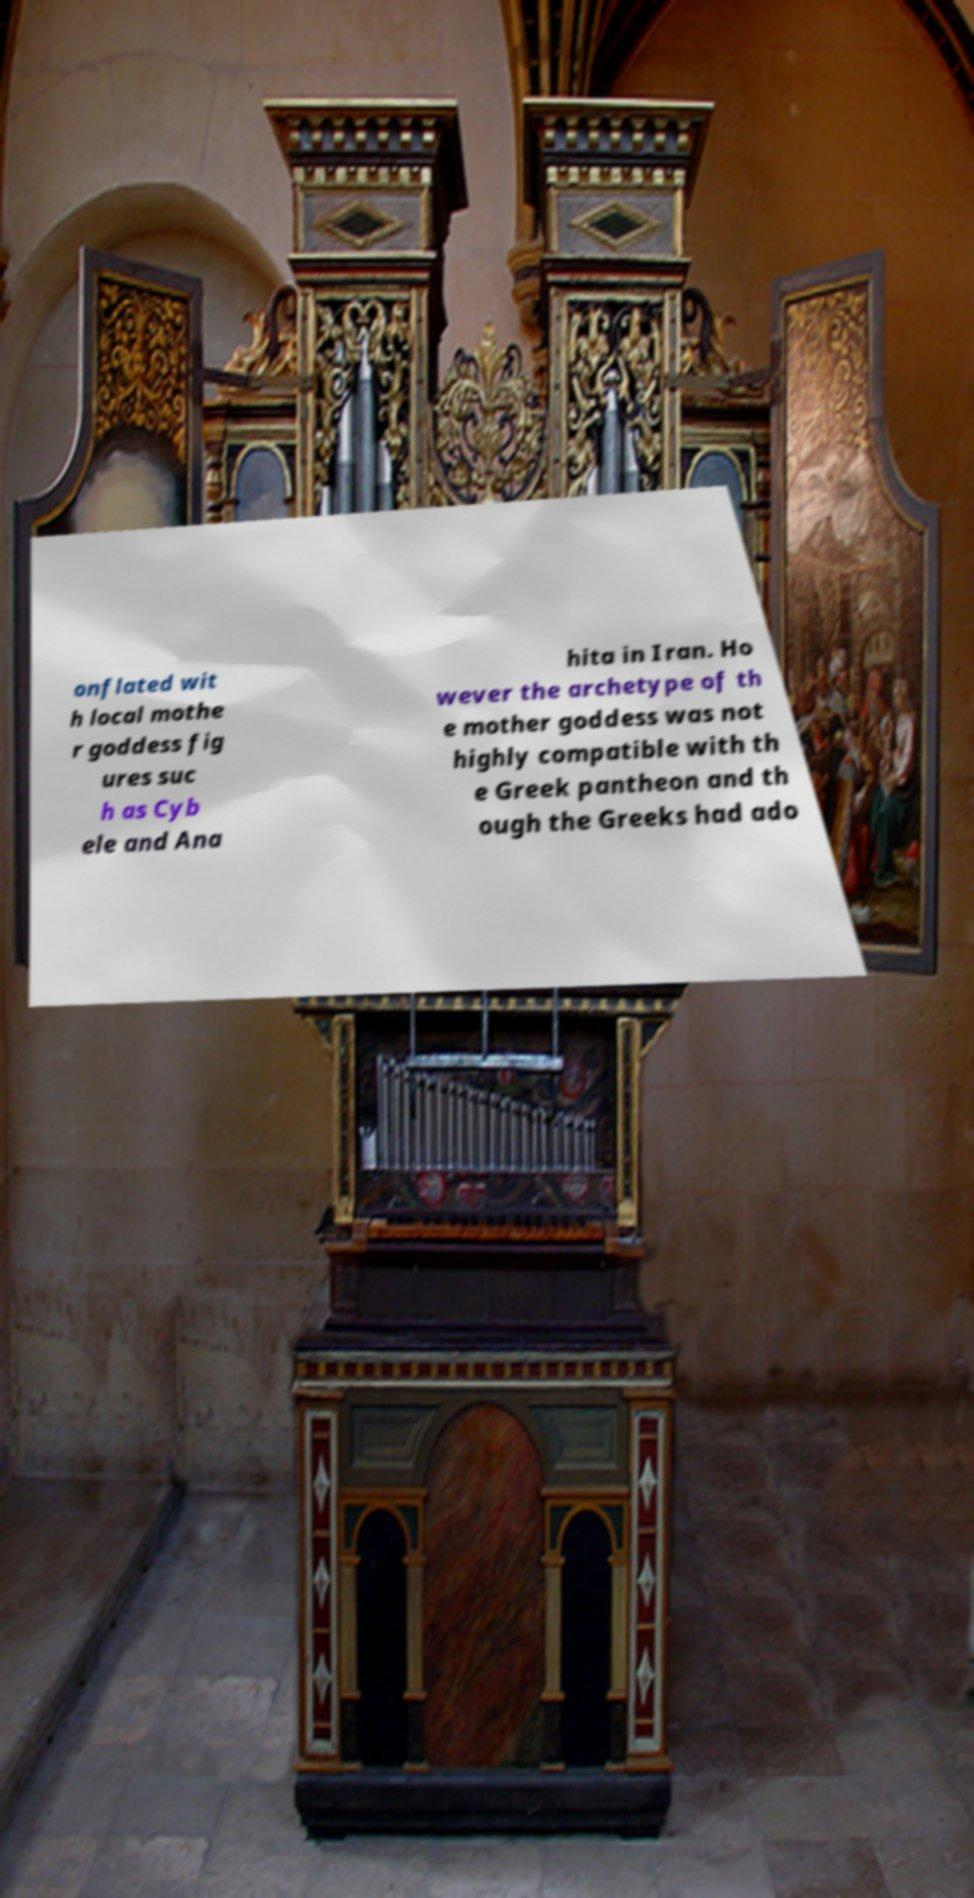What messages or text are displayed in this image? I need them in a readable, typed format. onflated wit h local mothe r goddess fig ures suc h as Cyb ele and Ana hita in Iran. Ho wever the archetype of th e mother goddess was not highly compatible with th e Greek pantheon and th ough the Greeks had ado 